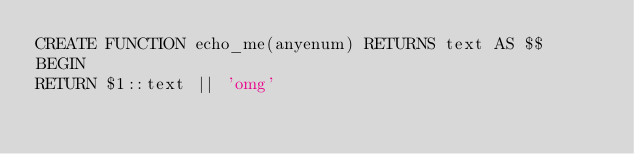Convert code to text. <code><loc_0><loc_0><loc_500><loc_500><_SQL_>CREATE FUNCTION echo_me(anyenum) RETURNS text AS $$
BEGIN
RETURN $1::text || 'omg'
</code> 